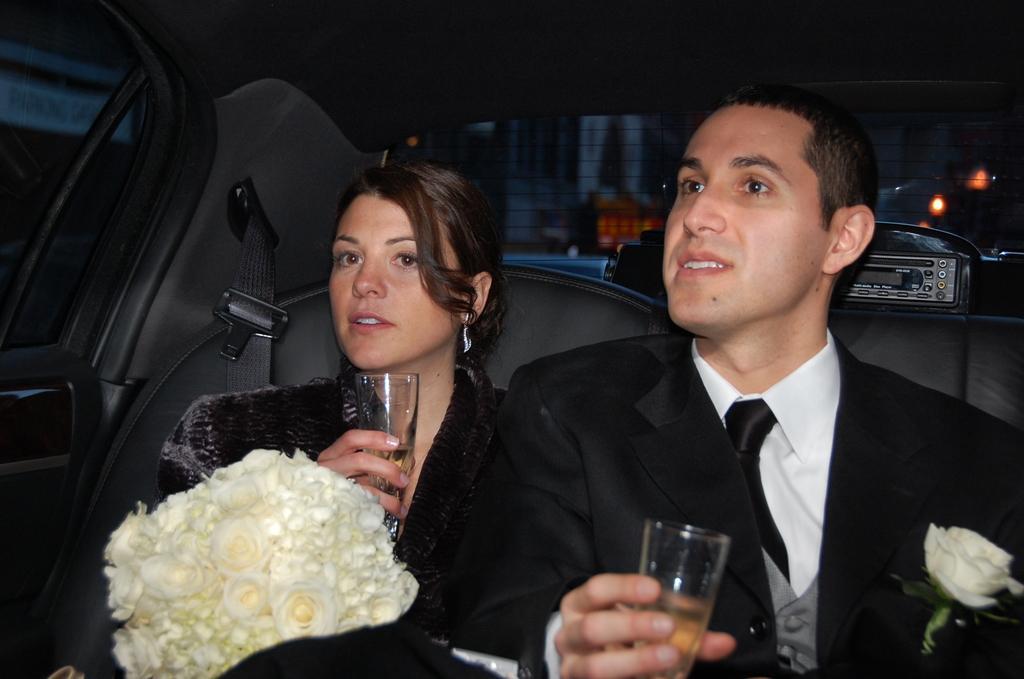How would you summarize this image in a sentence or two? It is the inside of the car view. Two peoples are sat on the seat. They are holding wine glasses some liquid on it. On right side person, He is wear coat, tie, shirt and there is a flower. On left side, woman is holding a bouquet. We can see some musical player at the back side. And here building is there. 